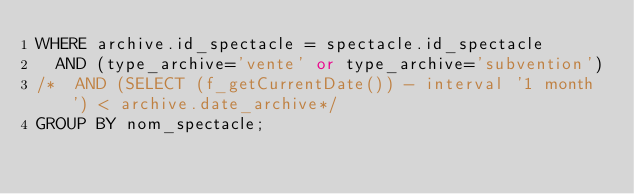<code> <loc_0><loc_0><loc_500><loc_500><_SQL_>WHERE archive.id_spectacle = spectacle.id_spectacle
  AND (type_archive='vente' or type_archive='subvention')
/*  AND (SELECT (f_getCurrentDate()) - interval '1 month') < archive.date_archive*/
GROUP BY nom_spectacle;
</code> 